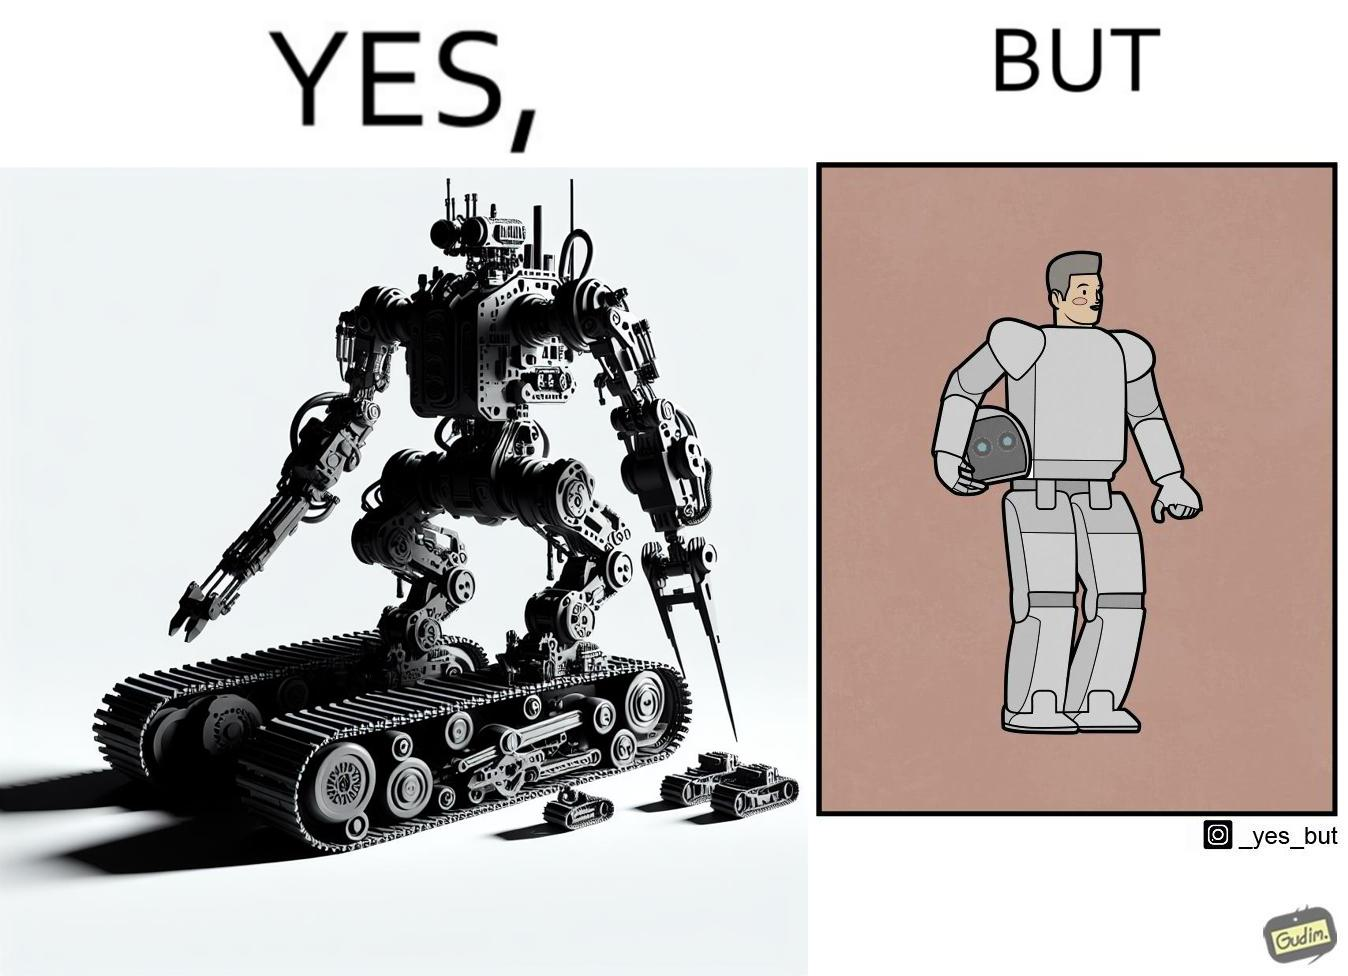Is this image satirical or non-satirical? Yes, this image is satirical. 